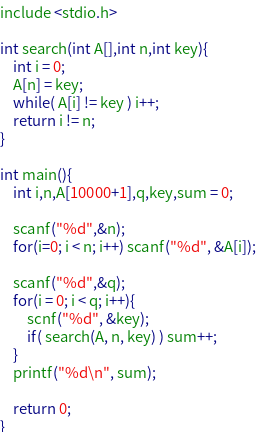<code> <loc_0><loc_0><loc_500><loc_500><_C_>include <stdio.h>

int search(int A[],int n,int key){
	int i = 0;
	A[n] = key; 
	while( A[i] != key ) i++;
	return i != n;
}

int main(){
	int i,n,A[10000+1],q,key,sum = 0;
	
	scanf("%d",&n);
	for(i=0; i < n; i++) scanf("%d", &A[i]);
	
	scanf("%d",&q);
	for(i = 0; i < q; i++){
		scnf("%d", &key);
		if( search(A, n, key) ) sum++;
	}
	printf("%d\n", sum);
	
	return 0;
}</code> 